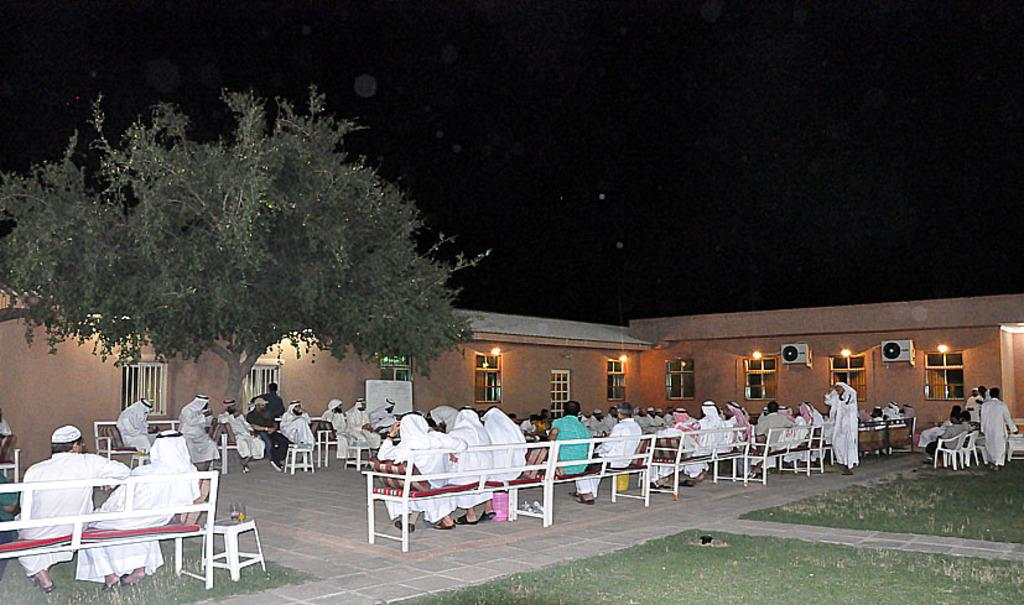What are the people in the image doing? The people in the image are sitting on tables. What type of structure can be seen in the image? There is a building in the image. What type of vegetation is present in the image? There is a tree in the image. What is the lighting condition at the top of the image? The top of the image appears to be dark. What book is the person reading in the image? There is no book present in the image; the people are sitting on tables. 